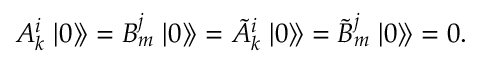<formula> <loc_0><loc_0><loc_500><loc_500>A _ { k } ^ { i } \left | 0 \right \rangle \, \right \rangle = B _ { m } ^ { j } \left | 0 \right \rangle \, \right \rangle = \tilde { A } _ { k } ^ { i } \left | 0 \right \rangle \, \right \rangle = \tilde { B } _ { m } ^ { j } \left | 0 \right \rangle \, \right \rangle = 0 .</formula> 